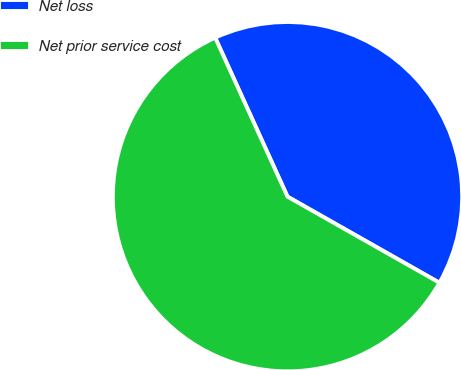Convert chart to OTSL. <chart><loc_0><loc_0><loc_500><loc_500><pie_chart><fcel>Net loss<fcel>Net prior service cost<nl><fcel>40.0%<fcel>60.0%<nl></chart> 